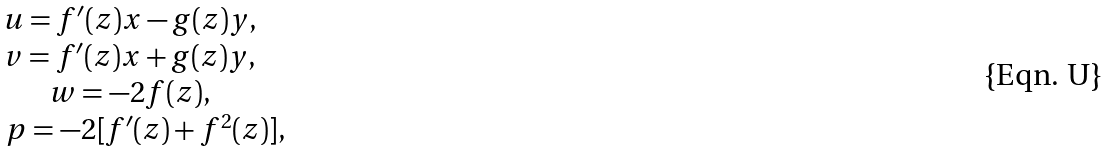Convert formula to latex. <formula><loc_0><loc_0><loc_500><loc_500>\begin{matrix} u = f ^ { \prime } ( z ) x - g ( z ) y , \quad \, \\ v = f ^ { \prime } ( z ) x + g ( z ) y , \quad \, \\ w = - 2 f ( z ) , \quad \, \\ p = - 2 [ f ^ { \prime } ( z ) + f ^ { 2 } ( z ) ] , \end{matrix}</formula> 